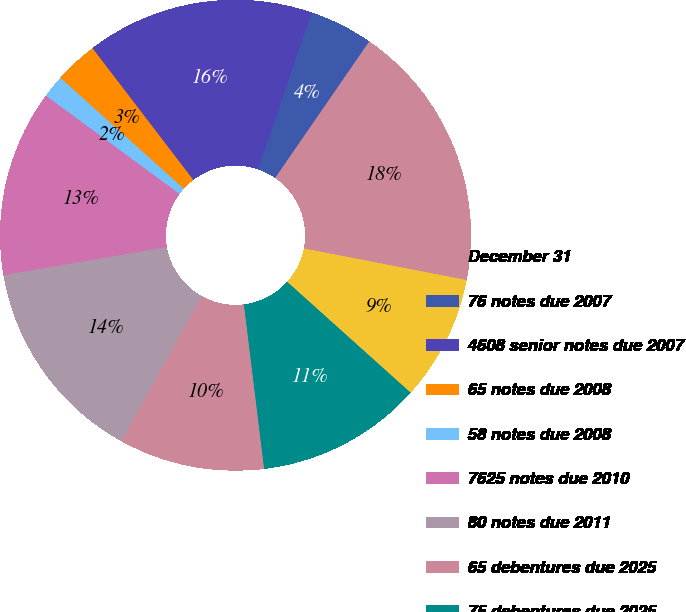Convert chart to OTSL. <chart><loc_0><loc_0><loc_500><loc_500><pie_chart><fcel>December 31<fcel>76 notes due 2007<fcel>4608 senior notes due 2007<fcel>65 notes due 2008<fcel>58 notes due 2008<fcel>7625 notes due 2010<fcel>80 notes due 2011<fcel>65 debentures due 2025<fcel>75 debentures due 2025<fcel>65 debentures due 2028<nl><fcel>18.45%<fcel>4.37%<fcel>15.63%<fcel>2.96%<fcel>1.55%<fcel>12.82%<fcel>14.22%<fcel>10.0%<fcel>11.41%<fcel>8.59%<nl></chart> 